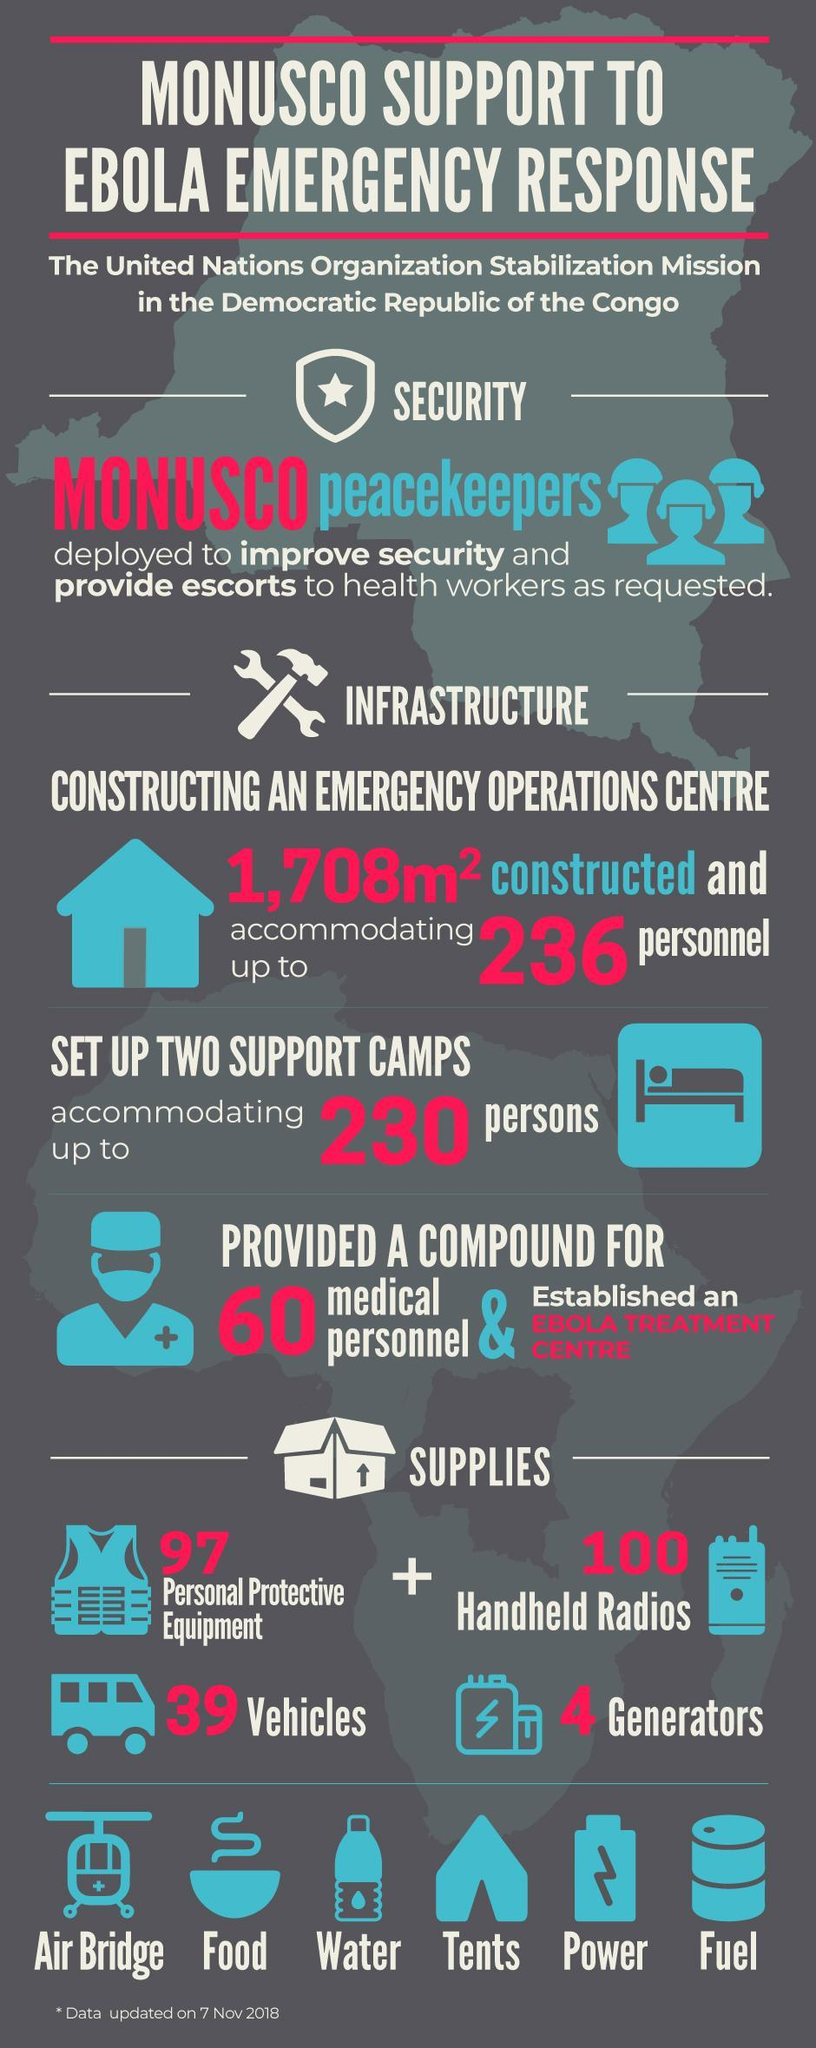What was the total number of supplies provided for Ebola Emergency response ?
Answer the question with a short phrase. 240 